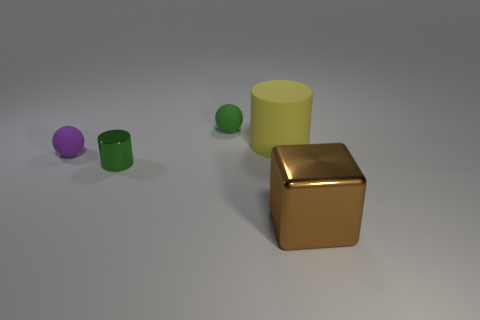Subtract all purple spheres. How many spheres are left? 1 Add 4 purple rubber balls. How many objects exist? 9 Subtract 1 balls. How many balls are left? 1 Subtract all cyan cylinders. Subtract all gray cubes. How many cylinders are left? 2 Subtract all purple spheres. Subtract all big yellow cylinders. How many objects are left? 3 Add 4 tiny purple balls. How many tiny purple balls are left? 5 Add 5 green matte objects. How many green matte objects exist? 6 Subtract 1 yellow cylinders. How many objects are left? 4 Subtract all cylinders. How many objects are left? 3 